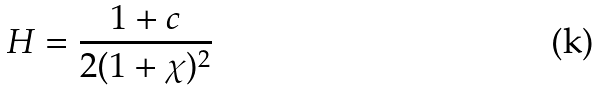<formula> <loc_0><loc_0><loc_500><loc_500>H = \frac { 1 + c } { 2 ( 1 + \chi ) ^ { 2 } }</formula> 